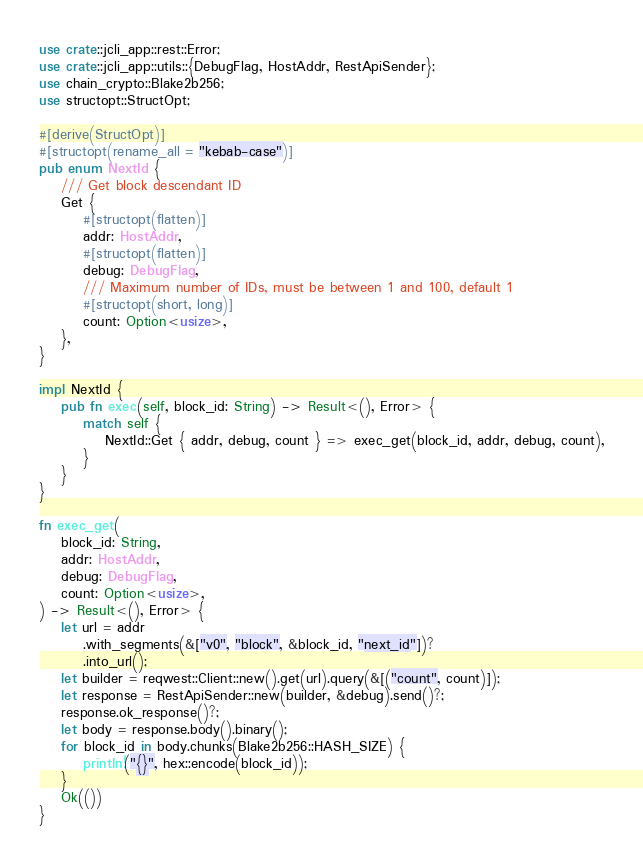Convert code to text. <code><loc_0><loc_0><loc_500><loc_500><_Rust_>use crate::jcli_app::rest::Error;
use crate::jcli_app::utils::{DebugFlag, HostAddr, RestApiSender};
use chain_crypto::Blake2b256;
use structopt::StructOpt;

#[derive(StructOpt)]
#[structopt(rename_all = "kebab-case")]
pub enum NextId {
    /// Get block descendant ID
    Get {
        #[structopt(flatten)]
        addr: HostAddr,
        #[structopt(flatten)]
        debug: DebugFlag,
        /// Maximum number of IDs, must be between 1 and 100, default 1
        #[structopt(short, long)]
        count: Option<usize>,
    },
}

impl NextId {
    pub fn exec(self, block_id: String) -> Result<(), Error> {
        match self {
            NextId::Get { addr, debug, count } => exec_get(block_id, addr, debug, count),
        }
    }
}

fn exec_get(
    block_id: String,
    addr: HostAddr,
    debug: DebugFlag,
    count: Option<usize>,
) -> Result<(), Error> {
    let url = addr
        .with_segments(&["v0", "block", &block_id, "next_id"])?
        .into_url();
    let builder = reqwest::Client::new().get(url).query(&[("count", count)]);
    let response = RestApiSender::new(builder, &debug).send()?;
    response.ok_response()?;
    let body = response.body().binary();
    for block_id in body.chunks(Blake2b256::HASH_SIZE) {
        println!("{}", hex::encode(block_id));
    }
    Ok(())
}
</code> 